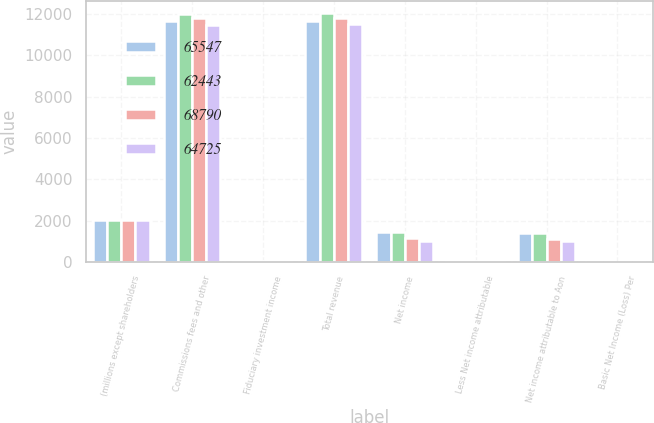Convert chart to OTSL. <chart><loc_0><loc_0><loc_500><loc_500><stacked_bar_chart><ecel><fcel>(millions except shareholders<fcel>Commissions fees and other<fcel>Fiduciary investment income<fcel>Total revenue<fcel>Net income<fcel>Less Net income attributable<fcel>Net income attributable to Aon<fcel>Basic Net Income (Loss) Per<nl><fcel>65547<fcel>2015<fcel>11661<fcel>21<fcel>11682<fcel>1422<fcel>37<fcel>1385<fcel>4.93<nl><fcel>62443<fcel>2014<fcel>12019<fcel>26<fcel>12045<fcel>1431<fcel>34<fcel>1397<fcel>4.73<nl><fcel>68790<fcel>2013<fcel>11787<fcel>28<fcel>11815<fcel>1148<fcel>35<fcel>1113<fcel>3.57<nl><fcel>64725<fcel>2012<fcel>11476<fcel>38<fcel>11514<fcel>1020<fcel>27<fcel>993<fcel>3.02<nl></chart> 